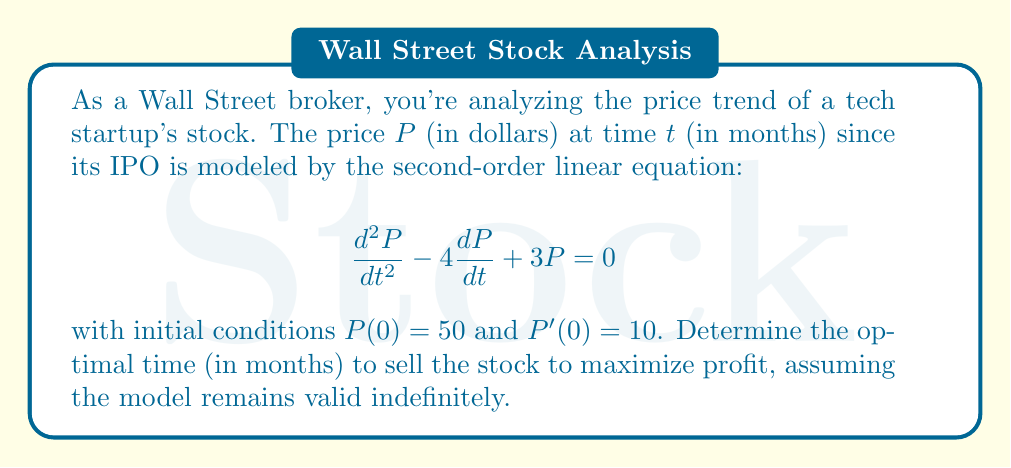Teach me how to tackle this problem. To solve this problem, we need to follow these steps:

1) First, we need to solve the second-order linear equation. The characteristic equation is:

   $$r^2 - 4r + 3 = 0$$

2) Solving this quadratic equation:
   
   $$r = \frac{4 \pm \sqrt{16 - 12}}{2} = \frac{4 \pm 2}{2}$$

   So, $r_1 = 3$ and $r_2 = 1$

3) The general solution is therefore:

   $$P(t) = c_1e^{3t} + c_2e^t$$

4) Using the initial conditions:

   $P(0) = 50$: $c_1 + c_2 = 50$
   $P'(0) = 10$: $3c_1 + c_2 = 10$

5) Solving these simultaneous equations:

   $c_2 = 50 - c_1$
   $3c_1 + (50 - c_1) = 10$
   $2c_1 = -40$
   $c_1 = -20$
   $c_2 = 70$

6) Therefore, the particular solution is:

   $$P(t) = -20e^{3t} + 70e^t$$

7) To find the maximum, we differentiate and set to zero:

   $$\frac{dP}{dt} = -60e^{3t} + 70e^t = 0$$

8) Solving this equation:

   $$e^{2t} = \frac{70}{60} = \frac{7}{6}$$

   $$2t = \ln(\frac{7}{6})$$

   $$t = \frac{1}{2}\ln(\frac{7}{6}) \approx 0.0770$$

9) To confirm this is a maximum, we can check the second derivative is negative at this point.

Therefore, the optimal time to sell is approximately 0.0770 months, or about 2.31 days after the IPO.
Answer: The optimal time to sell the stock is approximately 0.0770 months (about 2.31 days) after the IPO. 